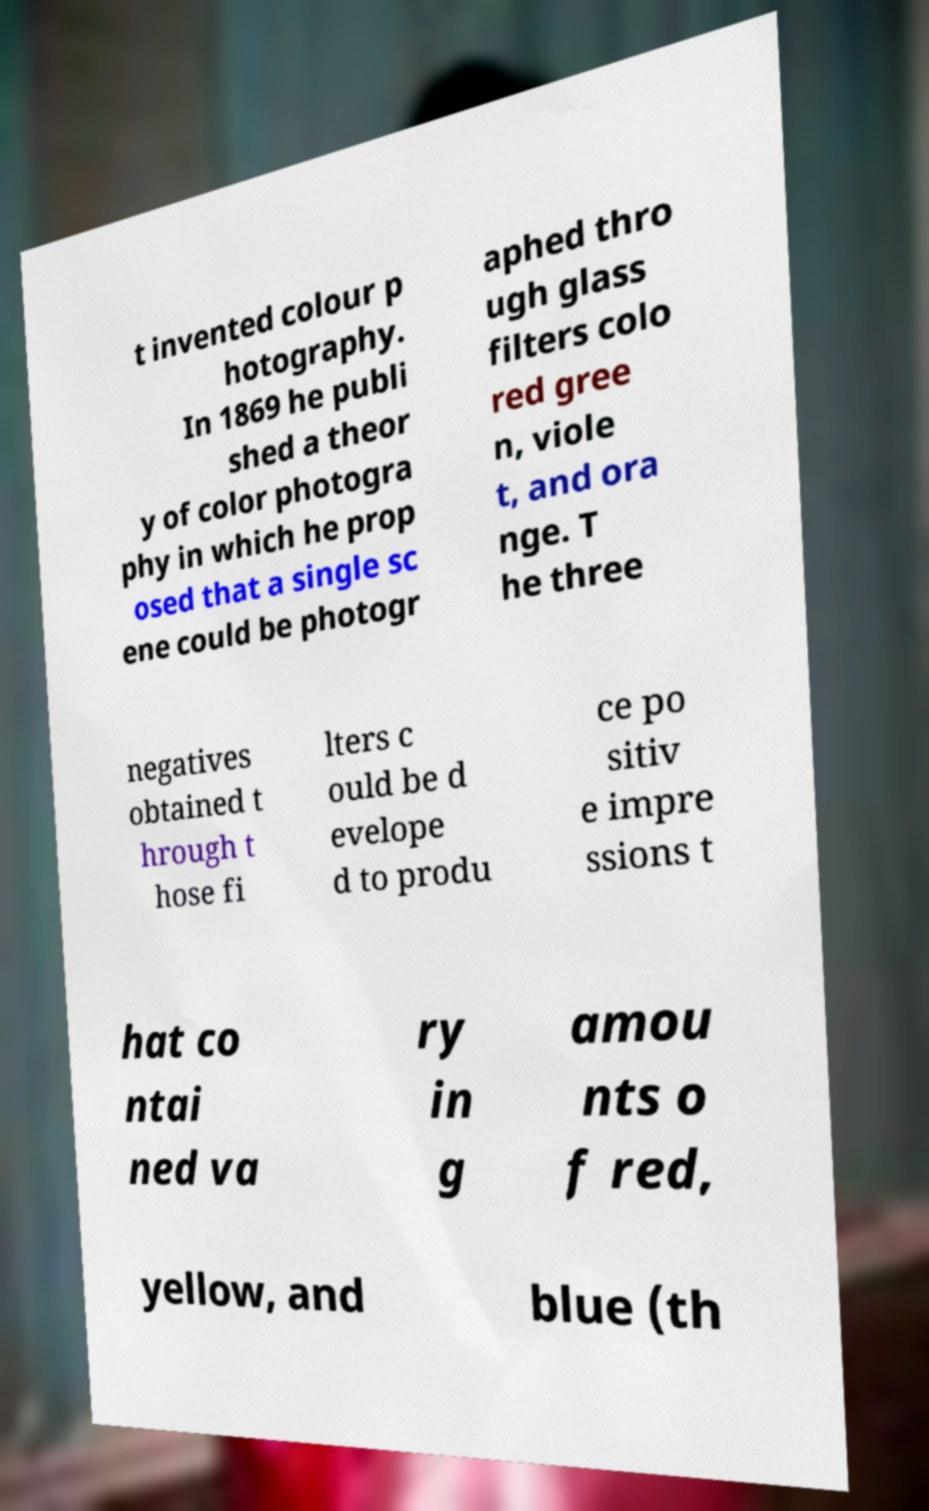There's text embedded in this image that I need extracted. Can you transcribe it verbatim? t invented colour p hotography. In 1869 he publi shed a theor y of color photogra phy in which he prop osed that a single sc ene could be photogr aphed thro ugh glass filters colo red gree n, viole t, and ora nge. T he three negatives obtained t hrough t hose fi lters c ould be d evelope d to produ ce po sitiv e impre ssions t hat co ntai ned va ry in g amou nts o f red, yellow, and blue (th 